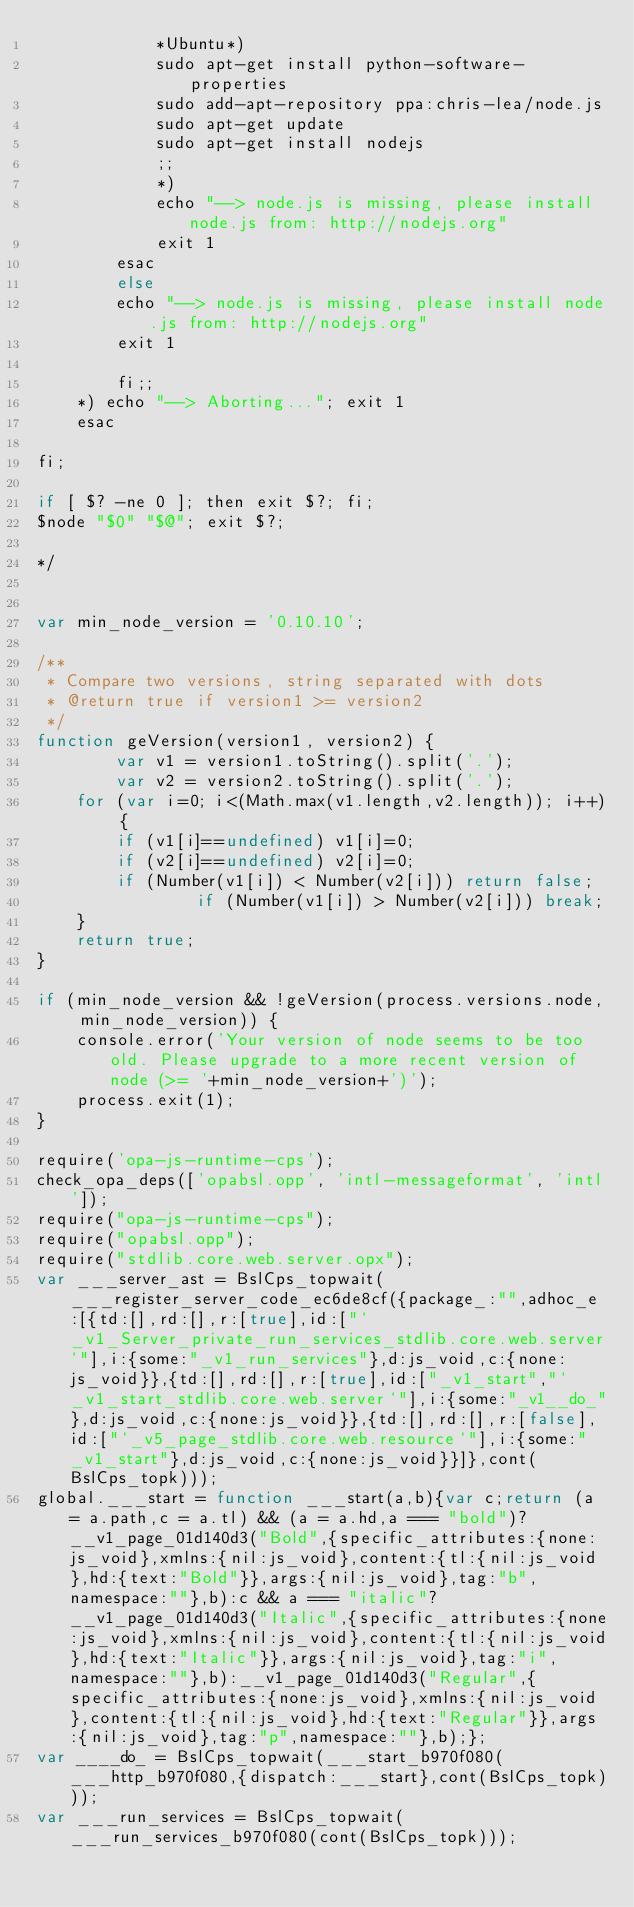<code> <loc_0><loc_0><loc_500><loc_500><_JavaScript_>            *Ubuntu*)
            sudo apt-get install python-software-properties
            sudo add-apt-repository ppa:chris-lea/node.js
            sudo apt-get update
            sudo apt-get install nodejs
            ;;
            *)
            echo "--> node.js is missing, please install node.js from: http://nodejs.org"
            exit 1
        esac
        else
        echo "--> node.js is missing, please install node.js from: http://nodejs.org"
        exit 1

        fi;;
    *) echo "--> Aborting..."; exit 1
    esac

fi;

if [ $? -ne 0 ]; then exit $?; fi;
$node "$0" "$@"; exit $?;

*/


var min_node_version = '0.10.10';

/**
 * Compare two versions, string separated with dots
 * @return true if version1 >= version2
 */
function geVersion(version1, version2) {
		var v1 = version1.toString().split('.');
		var v2 = version2.toString().split('.');
    for (var i=0; i<(Math.max(v1.length,v2.length)); i++) {
        if (v1[i]==undefined) v1[i]=0;
        if (v2[i]==undefined) v2[i]=0;
        if (Number(v1[i]) < Number(v2[i])) return false;
				if (Number(v1[i]) > Number(v2[i])) break;
    }
    return true;
}

if (min_node_version && !geVersion(process.versions.node, min_node_version)) {
    console.error('Your version of node seems to be too old. Please upgrade to a more recent version of node (>= '+min_node_version+')');
    process.exit(1);
}

require('opa-js-runtime-cps');
check_opa_deps(['opabsl.opp', 'intl-messageformat', 'intl']);
require("opa-js-runtime-cps");
require("opabsl.opp");
require("stdlib.core.web.server.opx");
var ___server_ast = BslCps_topwait(___register_server_code_ec6de8cf({package_:"",adhoc_e:[{td:[],rd:[],r:[true],id:["`_v1_Server_private_run_services_stdlib.core.web.server`"],i:{some:"_v1_run_services"},d:js_void,c:{none:js_void}},{td:[],rd:[],r:[true],id:["_v1_start","`_v1_start_stdlib.core.web.server`"],i:{some:"_v1__do_"},d:js_void,c:{none:js_void}},{td:[],rd:[],r:[false],id:["`_v5_page_stdlib.core.web.resource`"],i:{some:"_v1_start"},d:js_void,c:{none:js_void}}]},cont(BslCps_topk)));
global.___start = function ___start(a,b){var c;return (a = a.path,c = a.tl) && (a = a.hd,a === "bold")?__v1_page_01d140d3("Bold",{specific_attributes:{none:js_void},xmlns:{nil:js_void},content:{tl:{nil:js_void},hd:{text:"Bold"}},args:{nil:js_void},tag:"b",namespace:""},b):c && a === "italic"?__v1_page_01d140d3("Italic",{specific_attributes:{none:js_void},xmlns:{nil:js_void},content:{tl:{nil:js_void},hd:{text:"Italic"}},args:{nil:js_void},tag:"i",namespace:""},b):__v1_page_01d140d3("Regular",{specific_attributes:{none:js_void},xmlns:{nil:js_void},content:{tl:{nil:js_void},hd:{text:"Regular"}},args:{nil:js_void},tag:"p",namespace:""},b);};
var ____do_ = BslCps_topwait(___start_b970f080(___http_b970f080,{dispatch:___start},cont(BslCps_topk)));
var ___run_services = BslCps_topwait(___run_services_b970f080(cont(BslCps_topk)));
</code> 